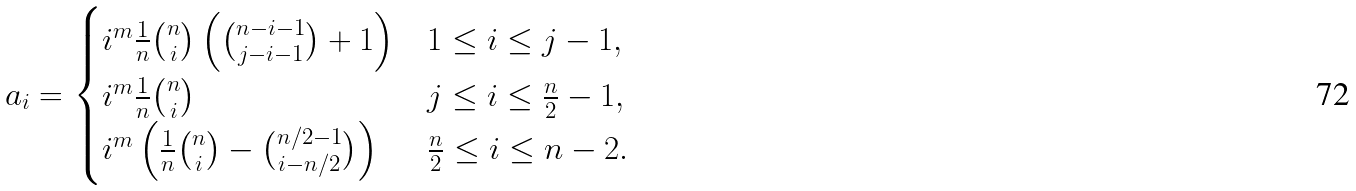<formula> <loc_0><loc_0><loc_500><loc_500>a _ { i } = \begin{cases} i ^ { m } \frac { 1 } { n } \binom { n } { i } \left ( \binom { n - i - 1 } { j - i - 1 } + 1 \right ) & 1 \leq i \leq j - 1 , \\ i ^ { m } \frac { 1 } { n } \binom { n } { i } & j \leq i \leq \frac { n } { 2 } - 1 , \\ i ^ { m } \left ( \frac { 1 } { n } \binom { n } { i } - \binom { n / 2 - 1 } { i - n / 2 } \right ) & \frac { n } { 2 } \leq i \leq n - 2 . \end{cases}</formula> 